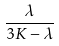<formula> <loc_0><loc_0><loc_500><loc_500>\frac { \lambda } { 3 K - \lambda }</formula> 